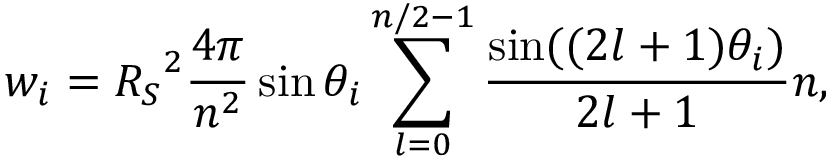<formula> <loc_0><loc_0><loc_500><loc_500>{ w _ { i } } = { R _ { S } } ^ { 2 } \frac { 4 \pi } { { { n ^ { 2 } } } } \sin { \theta _ { i } } \sum _ { l = 0 } ^ { n / 2 - 1 } { \frac { { \sin ( ( 2 l + 1 ) { \theta _ { i } } ) } } { 2 l + 1 } } n ,</formula> 